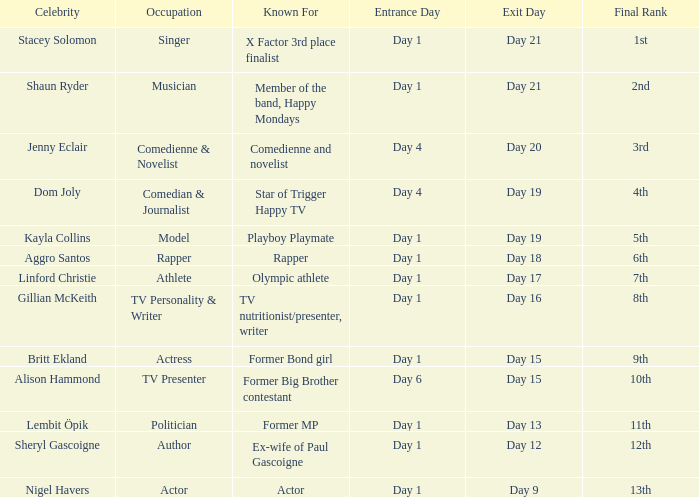In which place did the famous person, who entered on the first day and left on the 19th day, end up? 5th. 